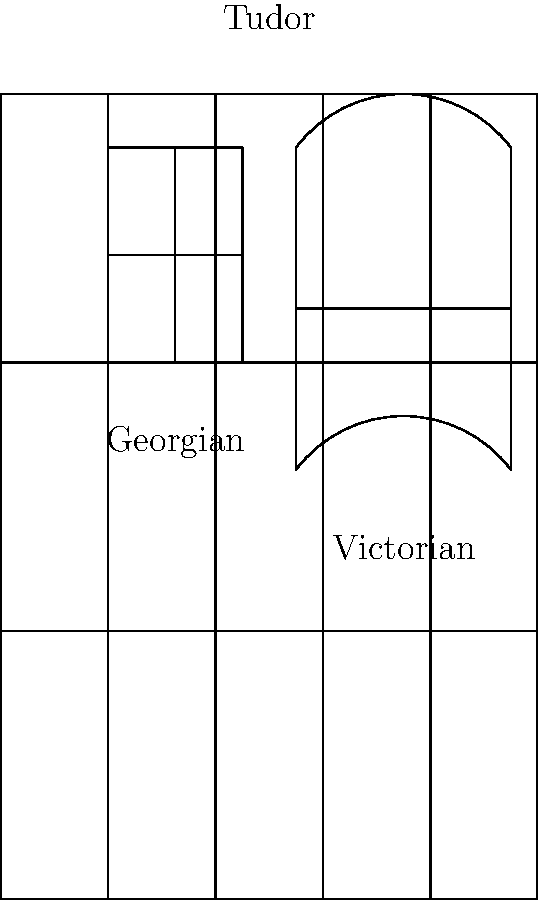Analyze the architectural elements depicted in the sketch of a Brixham building facade. Identify the three distinct architectural styles represented and explain how each style contributes to the overall historical character of the town. How does this combination of styles reflect Brixham's architectural evolution over time? To analyze the architectural elements and styles in the sketch:

1. Georgian style:
   - Identified by the symmetrical rectangular window on the left
   - Characterized by its divided panes (6 over 6)
   - Represents the 18th to early 19th century period

2. Victorian style:
   - Evident in the bay window in the center
   - Features a curved design with larger glass panes
   - Typical of the mid to late 19th century

3. Tudor style:
   - Visible in the timber framing across the entire facade
   - Characterized by exposed wooden beams creating a grid pattern
   - Originally from the 16th century but often revived in later periods

The combination of these styles reflects Brixham's architectural evolution:

1. Tudor elements suggest the town's medieval origins and fishing village roots.
2. Georgian features indicate growth and prosperity during the 18th century.
3. Victorian additions show further development and modernization in the 19th century.

This architectural mix demonstrates:
- Brixham's long history and continuous inhabitation
- The town's ability to adapt while preserving its heritage
- The influence of different historical periods on the local architecture

The overall character created by this combination:
- Gives Brixham a unique, layered historical appearance
- Showcases the town's evolution from a medieval fishing village to a thriving port
- Provides visual evidence of Brixham's economic and social changes over centuries

This architectural diversity makes Brixham an interesting subject for historical study and tourism, as each building tells a story of the town's development through time.
Answer: Georgian (symmetrical window), Victorian (bay window), and Tudor (timber framing) styles; reflects Brixham's evolution from medieval fishing village to prosperous port town over centuries. 